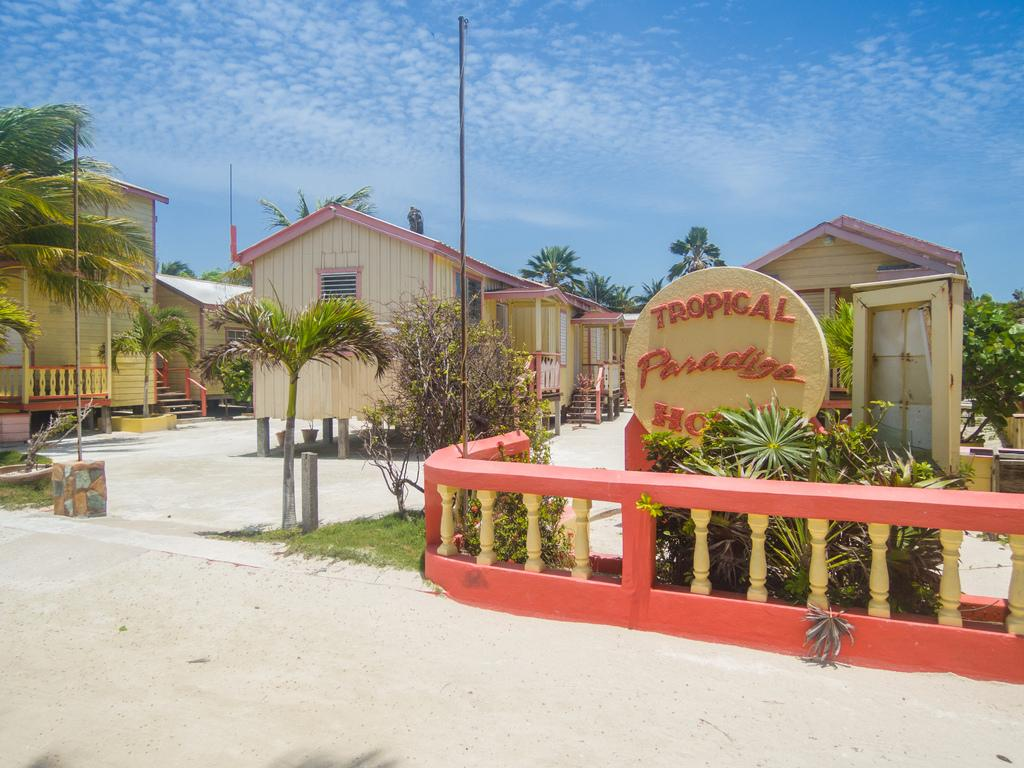What type of setting is depicted in the image? The image has an outside view. What can be seen in the foreground of the image? There are plants and sheds in the foreground. What is located in the middle of the image? There is a board in the middle of the image. What is visible in the background of the image? The sky is visible in the background. What type of guitar is being played in the image? There is no guitar present in the image. What selection of items can be seen on the board in the image? The board in the image does not show a selection of items; it is a standalone object. 